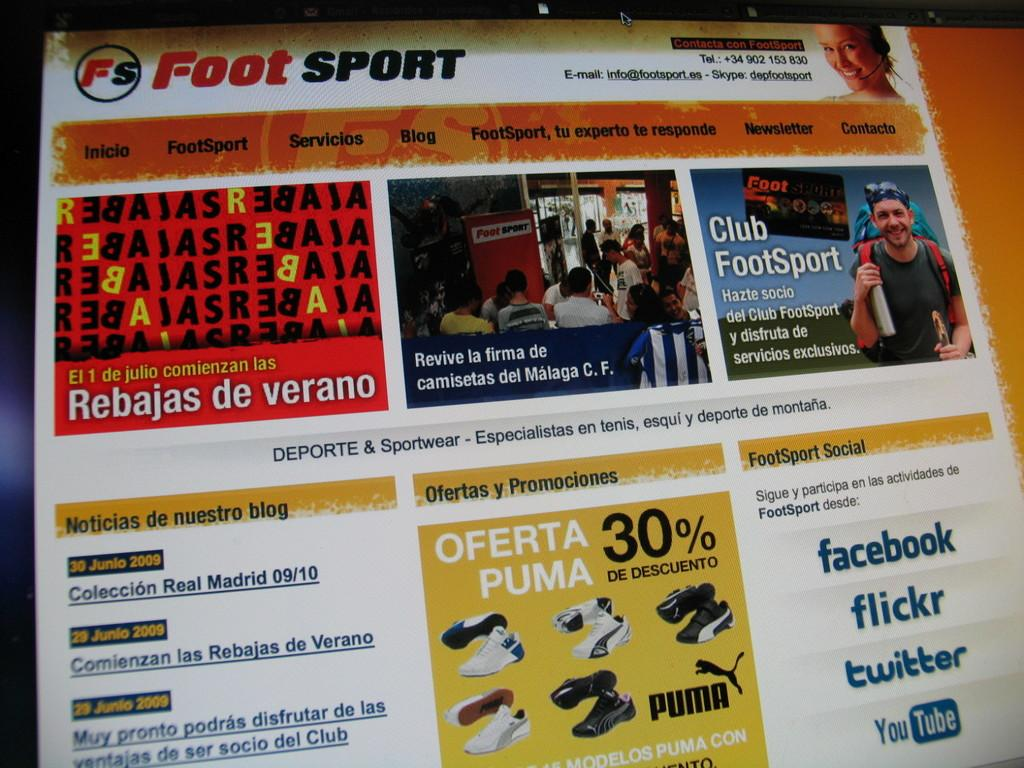What is the main object in the image? There is a screen in the image. What can be seen on the screen? Text and images are visible on the screen. What type of fruit is being used as a prop in the image? There is no fruit present in the image; it only features a screen with text and images. 